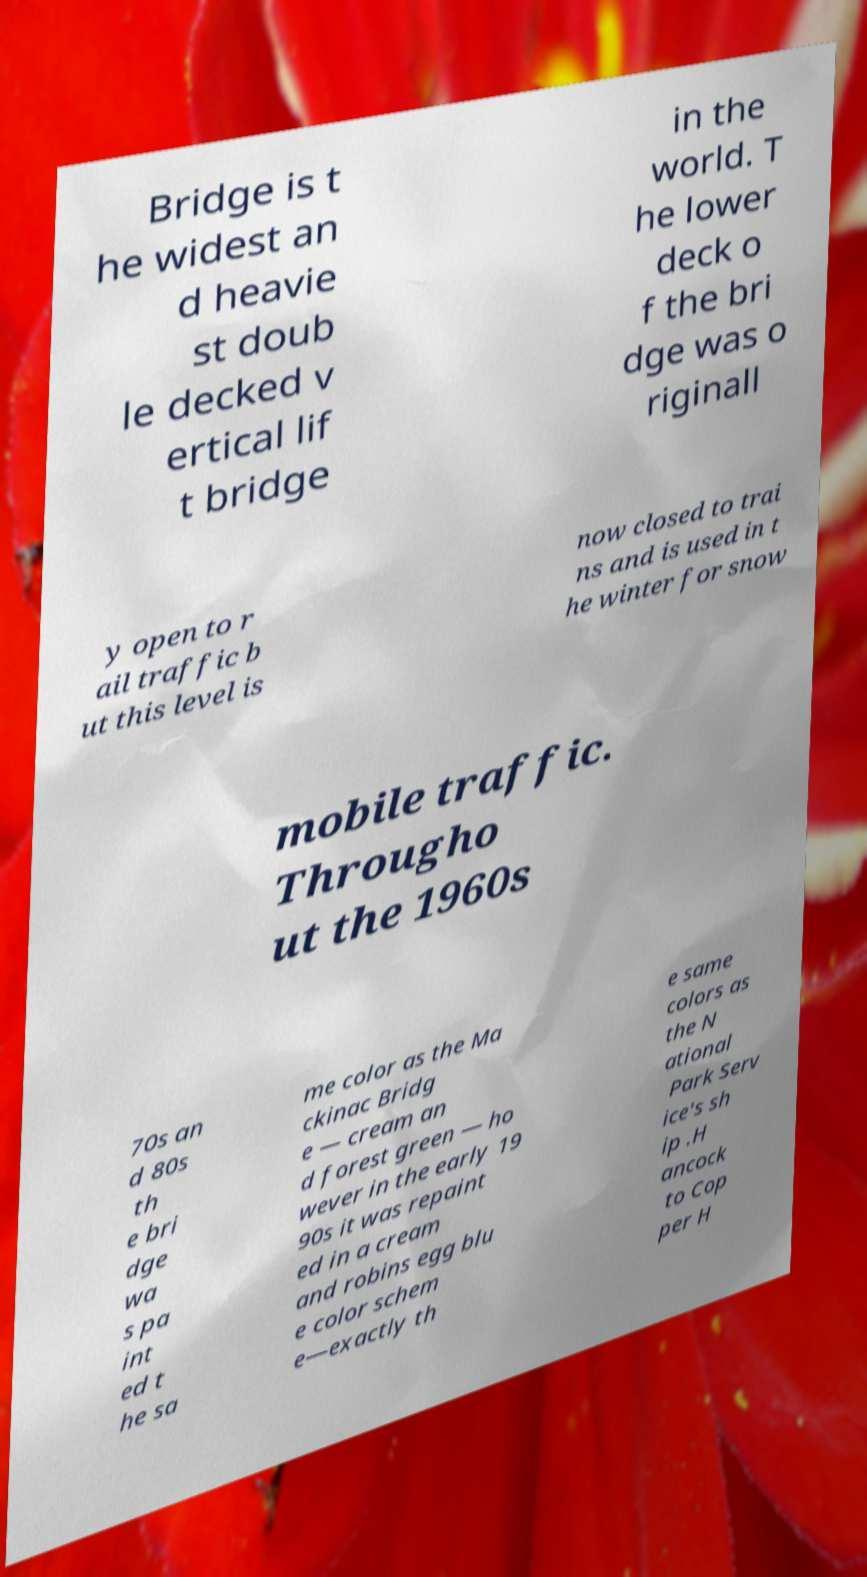Could you assist in decoding the text presented in this image and type it out clearly? Bridge is t he widest an d heavie st doub le decked v ertical lif t bridge in the world. T he lower deck o f the bri dge was o riginall y open to r ail traffic b ut this level is now closed to trai ns and is used in t he winter for snow mobile traffic. Througho ut the 1960s 70s an d 80s th e bri dge wa s pa int ed t he sa me color as the Ma ckinac Bridg e — cream an d forest green — ho wever in the early 19 90s it was repaint ed in a cream and robins egg blu e color schem e—exactly th e same colors as the N ational Park Serv ice's sh ip .H ancock to Cop per H 